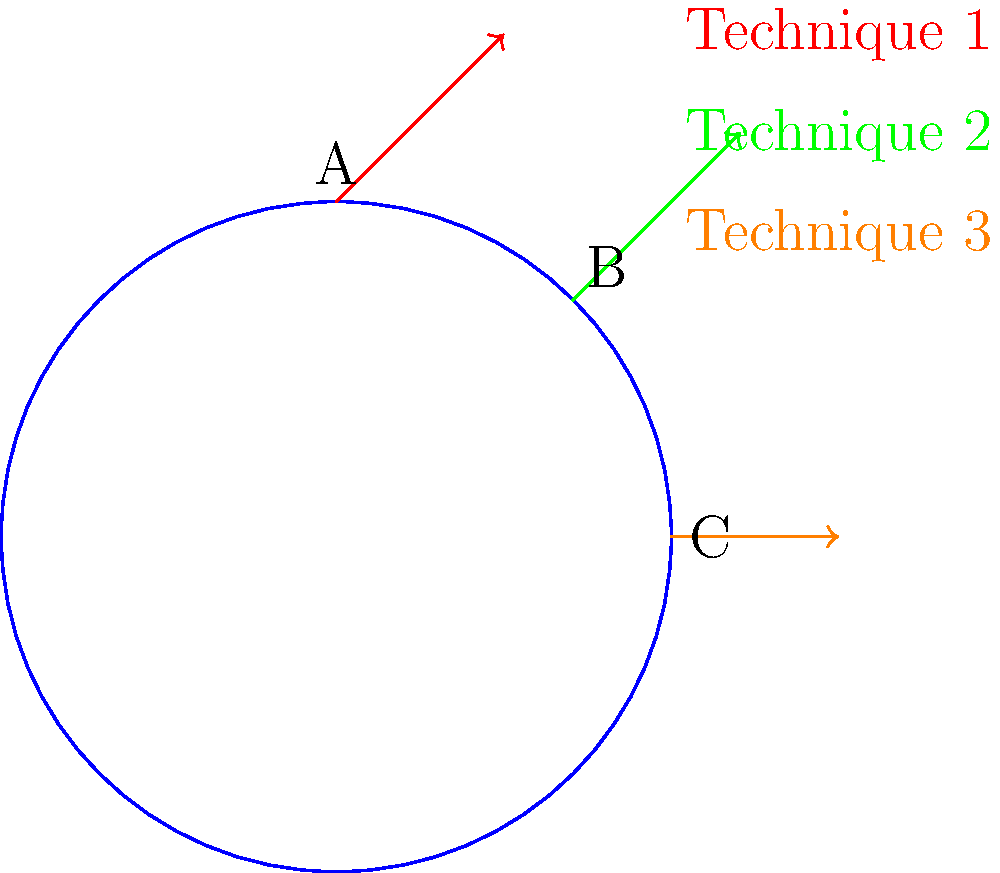In the diagram above, three different bicycle pedaling techniques are represented by force vectors (red, green, and orange) at different points on a circular pedal path. Which technique is likely to be the most efficient for power output during a cycling performance, and why? To determine the most efficient pedaling technique for power output, we need to consider the direction of the force vector relative to the circular pedal path:

1. Technique 1 (red vector at point A):
   - Force is applied vertically upward
   - Most of the force is perpendicular to the pedal's circular path
   - Minimal tangential component contributes to forward motion

2. Technique 2 (green vector at point B):
   - Force is applied at a 45-degree angle to the pedal path
   - Has both radial and tangential components
   - Moderate contribution to forward motion

3. Technique 3 (orange vector at point C):
   - Force is applied tangentially to the pedal path
   - Entire force contributes to forward motion
   - Maximizes power transfer to the bicycle

The efficiency of a pedaling technique is determined by how much of the applied force contributes to the forward motion of the bicycle. The tangential component of the force vector is responsible for this forward motion.

Technique 3 (orange vector) applies force completely tangential to the pedal path, ensuring that all of the cyclist's effort contributes to rotating the pedal and moving the bicycle forward. This makes it the most efficient technique for power output.

Technique 2 (green vector) is the second most efficient, as it has a significant tangential component, although some energy is lost in the radial direction.

Technique 1 (red vector) is the least efficient, as most of the force is applied radially, with minimal contribution to forward motion.
Answer: Technique 3 (orange vector), as it applies force tangentially to the pedal path, maximizing power transfer. 